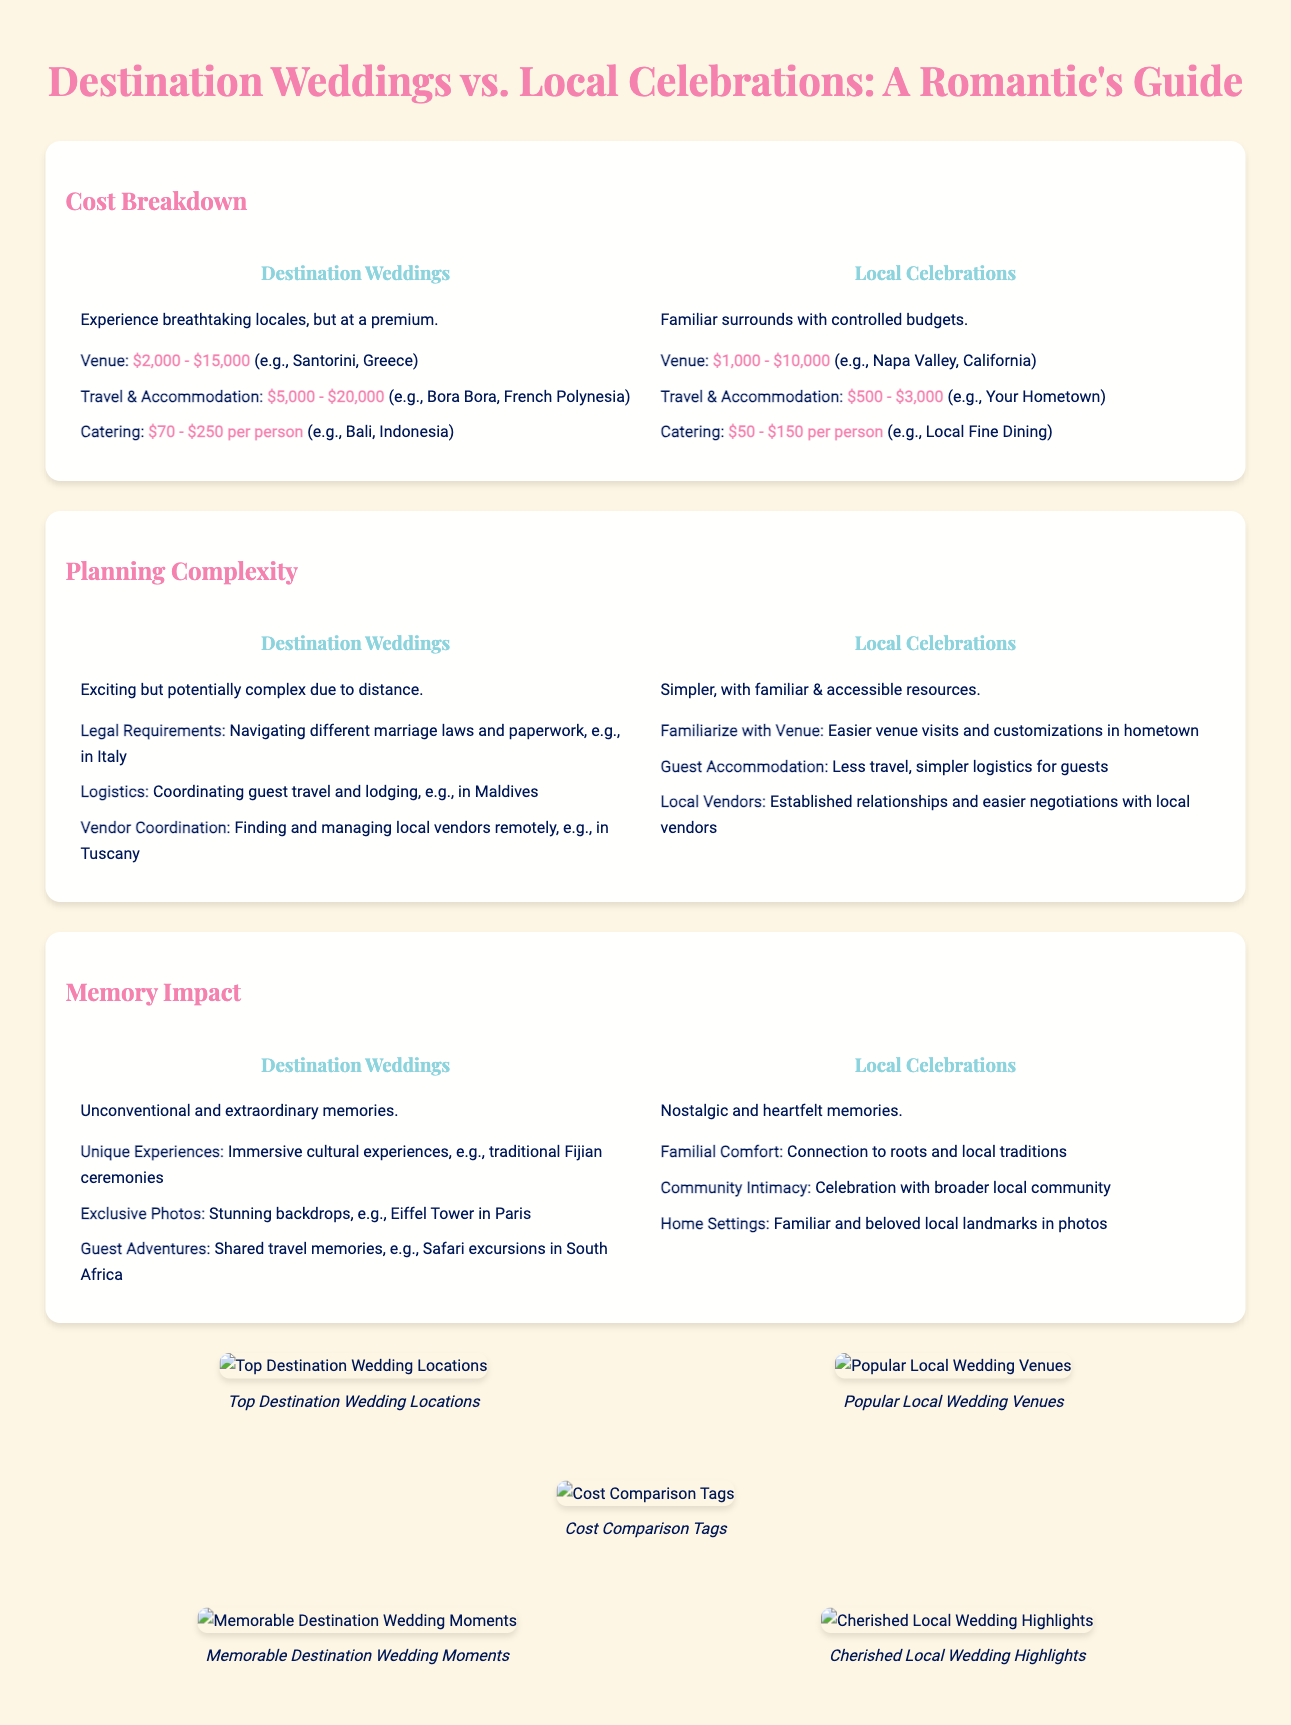what is the price range for a destination wedding venue? The document states that the price range for a destination wedding venue is between $2,000 and $15,000.
Answer: $2,000 - $15,000 what is the price range for local celebration catering per person? According to the infographic, local celebration catering costs between $50 and $150 per person.
Answer: $50 - $150 which type of wedding offers unique experiences through cultural immersion? The document indicates that destination weddings provide unique experiences, particularly through cultural immersion.
Answer: Destination weddings what is a challenge associated with planning a destination wedding? The infographic mentions that a challenge of planning a destination wedding includes navigating different marriage laws and paperwork.
Answer: Legal Requirements which venue type typically costs less for travel and accommodation? The cost of travel and accommodation is generally lower for local celebrations.
Answer: Local Celebrations how do guests experience shared adventures at weddings? The document highlights that destination weddings allow guests to experience shared travel memories through adventures.
Answer: Guest Adventures what unique photo opportunities do destination weddings provide? Destination weddings offer stunning backdrops for exclusive photos, such as the Eiffel Tower in Paris.
Answer: Exclusive Photos which type of celebration emphasizes familial comfort and local traditions? The infographic states that local celebrations emphasize connection to roots and local traditions, thus offering familial comfort.
Answer: Local Celebrations what visual element compares the costs associated with destination and local weddings? The cost comparison tags visual element illustrates the price differences for destination and local weddings.
Answer: Cost Comparison Tags 